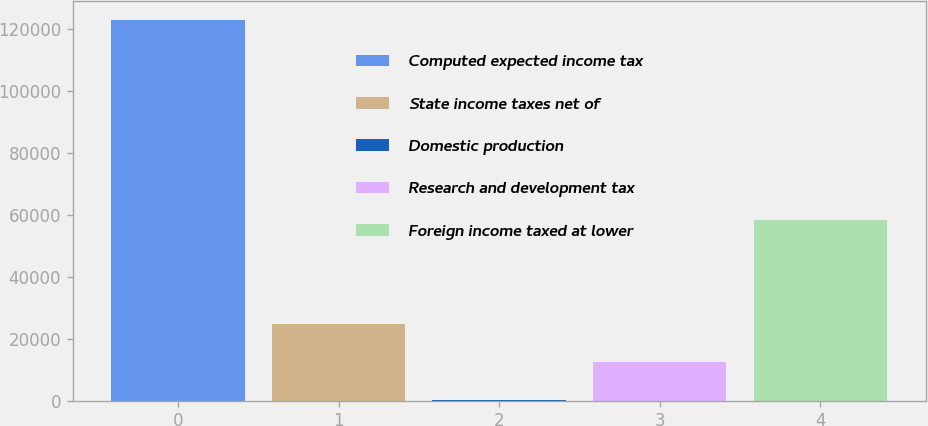Convert chart to OTSL. <chart><loc_0><loc_0><loc_500><loc_500><bar_chart><fcel>Computed expected income tax<fcel>State income taxes net of<fcel>Domestic production<fcel>Research and development tax<fcel>Foreign income taxed at lower<nl><fcel>122845<fcel>24774.6<fcel>257<fcel>12515.8<fcel>58489<nl></chart> 